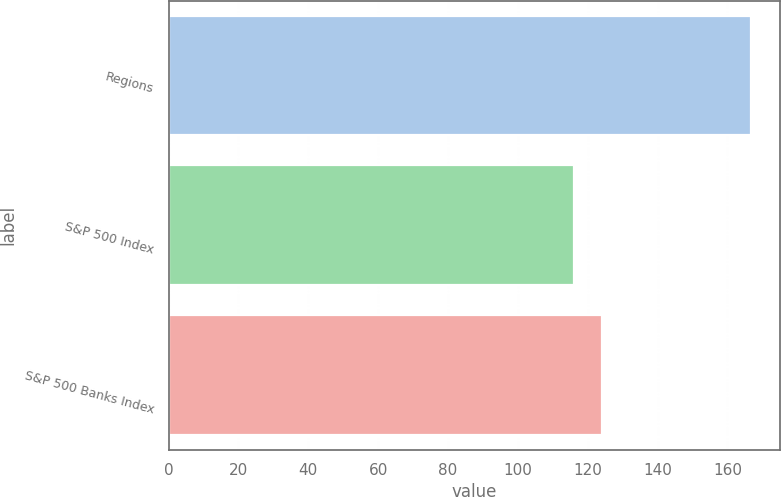Convert chart to OTSL. <chart><loc_0><loc_0><loc_500><loc_500><bar_chart><fcel>Regions<fcel>S&P 500 Index<fcel>S&P 500 Banks Index<nl><fcel>166.82<fcel>115.99<fcel>124.06<nl></chart> 